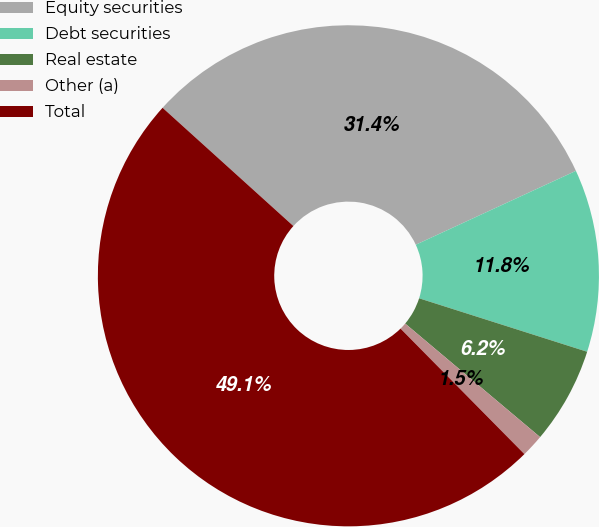Convert chart. <chart><loc_0><loc_0><loc_500><loc_500><pie_chart><fcel>Equity securities<fcel>Debt securities<fcel>Real estate<fcel>Other (a)<fcel>Total<nl><fcel>31.42%<fcel>11.78%<fcel>6.23%<fcel>1.47%<fcel>49.09%<nl></chart> 